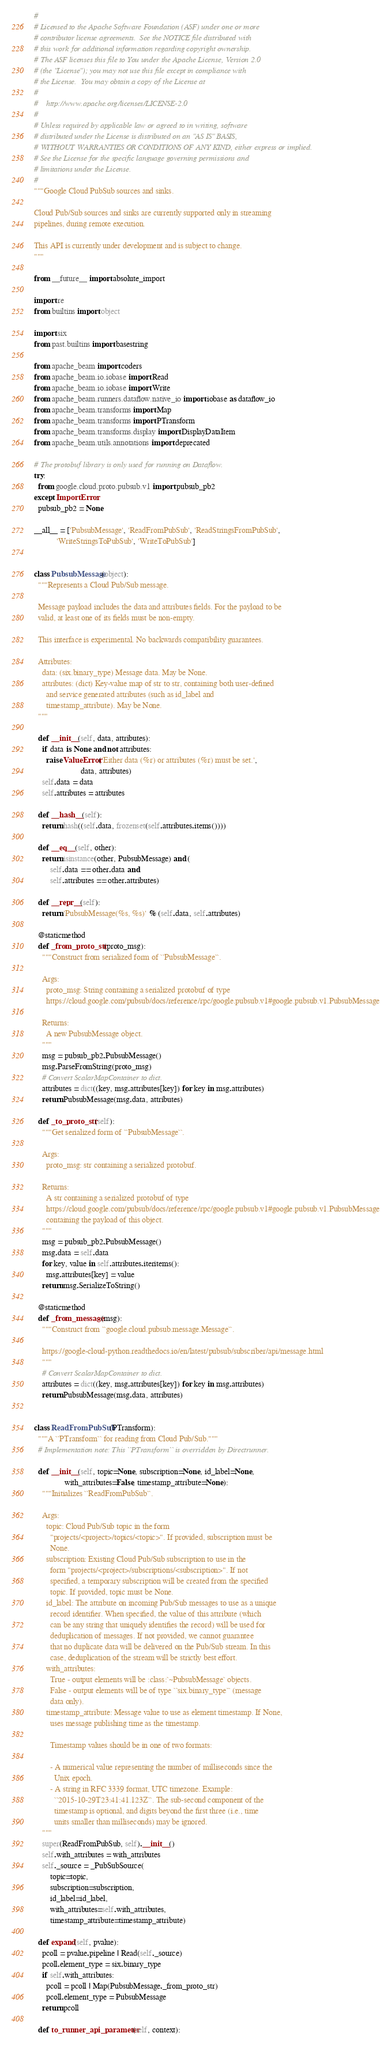Convert code to text. <code><loc_0><loc_0><loc_500><loc_500><_Python_>#
# Licensed to the Apache Software Foundation (ASF) under one or more
# contributor license agreements.  See the NOTICE file distributed with
# this work for additional information regarding copyright ownership.
# The ASF licenses this file to You under the Apache License, Version 2.0
# (the "License"); you may not use this file except in compliance with
# the License.  You may obtain a copy of the License at
#
#    http://www.apache.org/licenses/LICENSE-2.0
#
# Unless required by applicable law or agreed to in writing, software
# distributed under the License is distributed on an "AS IS" BASIS,
# WITHOUT WARRANTIES OR CONDITIONS OF ANY KIND, either express or implied.
# See the License for the specific language governing permissions and
# limitations under the License.
#
"""Google Cloud PubSub sources and sinks.

Cloud Pub/Sub sources and sinks are currently supported only in streaming
pipelines, during remote execution.

This API is currently under development and is subject to change.
"""

from __future__ import absolute_import

import re
from builtins import object

import six
from past.builtins import basestring

from apache_beam import coders
from apache_beam.io.iobase import Read
from apache_beam.io.iobase import Write
from apache_beam.runners.dataflow.native_io import iobase as dataflow_io
from apache_beam.transforms import Map
from apache_beam.transforms import PTransform
from apache_beam.transforms.display import DisplayDataItem
from apache_beam.utils.annotations import deprecated

# The protobuf library is only used for running on Dataflow.
try:
  from google.cloud.proto.pubsub.v1 import pubsub_pb2
except ImportError:
  pubsub_pb2 = None

__all__ = ['PubsubMessage', 'ReadFromPubSub', 'ReadStringsFromPubSub',
           'WriteStringsToPubSub', 'WriteToPubSub']


class PubsubMessage(object):
  """Represents a Cloud Pub/Sub message.

  Message payload includes the data and attributes fields. For the payload to be
  valid, at least one of its fields must be non-empty.

  This interface is experimental. No backwards compatibility guarantees.

  Attributes:
    data: (six.binary_type) Message data. May be None.
    attributes: (dict) Key-value map of str to str, containing both user-defined
      and service generated attributes (such as id_label and
      timestamp_attribute). May be None.
  """

  def __init__(self, data, attributes):
    if data is None and not attributes:
      raise ValueError('Either data (%r) or attributes (%r) must be set.',
                       data, attributes)
    self.data = data
    self.attributes = attributes

  def __hash__(self):
    return hash((self.data, frozenset(self.attributes.items())))

  def __eq__(self, other):
    return isinstance(other, PubsubMessage) and (
        self.data == other.data and
        self.attributes == other.attributes)

  def __repr__(self):
    return 'PubsubMessage(%s, %s)' % (self.data, self.attributes)

  @staticmethod
  def _from_proto_str(proto_msg):
    """Construct from serialized form of ``PubsubMessage``.

    Args:
      proto_msg: String containing a serialized protobuf of type
      https://cloud.google.com/pubsub/docs/reference/rpc/google.pubsub.v1#google.pubsub.v1.PubsubMessage

    Returns:
      A new PubsubMessage object.
    """
    msg = pubsub_pb2.PubsubMessage()
    msg.ParseFromString(proto_msg)
    # Convert ScalarMapContainer to dict.
    attributes = dict((key, msg.attributes[key]) for key in msg.attributes)
    return PubsubMessage(msg.data, attributes)

  def _to_proto_str(self):
    """Get serialized form of ``PubsubMessage``.

    Args:
      proto_msg: str containing a serialized protobuf.

    Returns:
      A str containing a serialized protobuf of type
      https://cloud.google.com/pubsub/docs/reference/rpc/google.pubsub.v1#google.pubsub.v1.PubsubMessage
      containing the payload of this object.
    """
    msg = pubsub_pb2.PubsubMessage()
    msg.data = self.data
    for key, value in self.attributes.iteritems():
      msg.attributes[key] = value
    return msg.SerializeToString()

  @staticmethod
  def _from_message(msg):
    """Construct from ``google.cloud.pubsub.message.Message``.

    https://google-cloud-python.readthedocs.io/en/latest/pubsub/subscriber/api/message.html
    """
    # Convert ScalarMapContainer to dict.
    attributes = dict((key, msg.attributes[key]) for key in msg.attributes)
    return PubsubMessage(msg.data, attributes)


class ReadFromPubSub(PTransform):
  """A ``PTransform`` for reading from Cloud Pub/Sub."""
  # Implementation note: This ``PTransform`` is overridden by Directrunner.

  def __init__(self, topic=None, subscription=None, id_label=None,
               with_attributes=False, timestamp_attribute=None):
    """Initializes ``ReadFromPubSub``.

    Args:
      topic: Cloud Pub/Sub topic in the form
        "projects/<project>/topics/<topic>". If provided, subscription must be
        None.
      subscription: Existing Cloud Pub/Sub subscription to use in the
        form "projects/<project>/subscriptions/<subscription>". If not
        specified, a temporary subscription will be created from the specified
        topic. If provided, topic must be None.
      id_label: The attribute on incoming Pub/Sub messages to use as a unique
        record identifier. When specified, the value of this attribute (which
        can be any string that uniquely identifies the record) will be used for
        deduplication of messages. If not provided, we cannot guarantee
        that no duplicate data will be delivered on the Pub/Sub stream. In this
        case, deduplication of the stream will be strictly best effort.
      with_attributes:
        True - output elements will be :class:`~PubsubMessage` objects.
        False - output elements will be of type ``six.binary_type`` (message
        data only).
      timestamp_attribute: Message value to use as element timestamp. If None,
        uses message publishing time as the timestamp.

        Timestamp values should be in one of two formats:

        - A numerical value representing the number of milliseconds since the
          Unix epoch.
        - A string in RFC 3339 format, UTC timezone. Example:
          ``2015-10-29T23:41:41.123Z``. The sub-second component of the
          timestamp is optional, and digits beyond the first three (i.e., time
          units smaller than milliseconds) may be ignored.
    """
    super(ReadFromPubSub, self).__init__()
    self.with_attributes = with_attributes
    self._source = _PubSubSource(
        topic=topic,
        subscription=subscription,
        id_label=id_label,
        with_attributes=self.with_attributes,
        timestamp_attribute=timestamp_attribute)

  def expand(self, pvalue):
    pcoll = pvalue.pipeline | Read(self._source)
    pcoll.element_type = six.binary_type
    if self.with_attributes:
      pcoll = pcoll | Map(PubsubMessage._from_proto_str)
      pcoll.element_type = PubsubMessage
    return pcoll

  def to_runner_api_parameter(self, context):</code> 